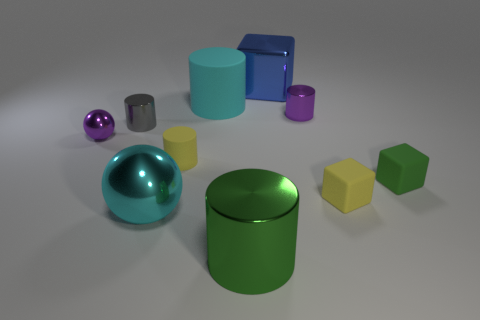How many objects of different colors are there, and can you list their shapes and colors? In the image, there are objects in six distinct colors. They are as follows: one purple sphere, one purple cylinder, one blue cube, one green cylinder, one yellow cylinder, and two yellow cubes. 